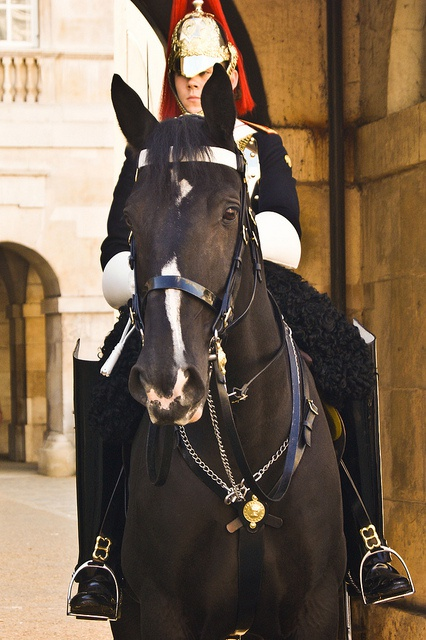Describe the objects in this image and their specific colors. I can see horse in lightgray, black, gray, and maroon tones and people in beige, black, ivory, maroon, and tan tones in this image. 